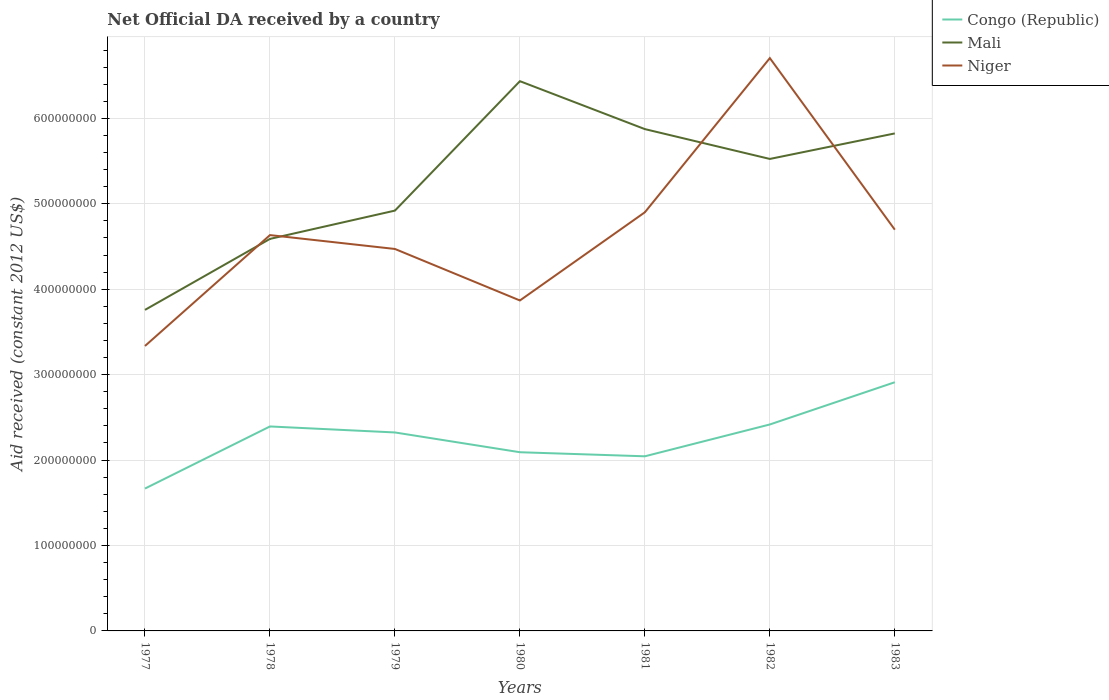Does the line corresponding to Congo (Republic) intersect with the line corresponding to Mali?
Offer a very short reply. No. Across all years, what is the maximum net official development assistance aid received in Congo (Republic)?
Your answer should be compact. 1.67e+08. In which year was the net official development assistance aid received in Congo (Republic) maximum?
Provide a short and direct response. 1977. What is the total net official development assistance aid received in Niger in the graph?
Provide a short and direct response. -1.36e+08. What is the difference between the highest and the second highest net official development assistance aid received in Mali?
Provide a short and direct response. 2.68e+08. How many years are there in the graph?
Provide a short and direct response. 7. Does the graph contain grids?
Keep it short and to the point. Yes. How many legend labels are there?
Your answer should be compact. 3. How are the legend labels stacked?
Keep it short and to the point. Vertical. What is the title of the graph?
Provide a short and direct response. Net Official DA received by a country. Does "European Union" appear as one of the legend labels in the graph?
Keep it short and to the point. No. What is the label or title of the Y-axis?
Your response must be concise. Aid received (constant 2012 US$). What is the Aid received (constant 2012 US$) in Congo (Republic) in 1977?
Offer a very short reply. 1.67e+08. What is the Aid received (constant 2012 US$) in Mali in 1977?
Keep it short and to the point. 3.76e+08. What is the Aid received (constant 2012 US$) of Niger in 1977?
Your answer should be very brief. 3.34e+08. What is the Aid received (constant 2012 US$) in Congo (Republic) in 1978?
Your response must be concise. 2.39e+08. What is the Aid received (constant 2012 US$) of Mali in 1978?
Your answer should be very brief. 4.59e+08. What is the Aid received (constant 2012 US$) in Niger in 1978?
Give a very brief answer. 4.63e+08. What is the Aid received (constant 2012 US$) in Congo (Republic) in 1979?
Offer a very short reply. 2.32e+08. What is the Aid received (constant 2012 US$) in Mali in 1979?
Your answer should be very brief. 4.92e+08. What is the Aid received (constant 2012 US$) of Niger in 1979?
Keep it short and to the point. 4.47e+08. What is the Aid received (constant 2012 US$) in Congo (Republic) in 1980?
Your answer should be very brief. 2.09e+08. What is the Aid received (constant 2012 US$) in Mali in 1980?
Your answer should be very brief. 6.44e+08. What is the Aid received (constant 2012 US$) in Niger in 1980?
Give a very brief answer. 3.87e+08. What is the Aid received (constant 2012 US$) in Congo (Republic) in 1981?
Your answer should be very brief. 2.04e+08. What is the Aid received (constant 2012 US$) of Mali in 1981?
Keep it short and to the point. 5.87e+08. What is the Aid received (constant 2012 US$) of Niger in 1981?
Ensure brevity in your answer.  4.90e+08. What is the Aid received (constant 2012 US$) of Congo (Republic) in 1982?
Ensure brevity in your answer.  2.42e+08. What is the Aid received (constant 2012 US$) of Mali in 1982?
Ensure brevity in your answer.  5.53e+08. What is the Aid received (constant 2012 US$) of Niger in 1982?
Give a very brief answer. 6.71e+08. What is the Aid received (constant 2012 US$) in Congo (Republic) in 1983?
Provide a short and direct response. 2.91e+08. What is the Aid received (constant 2012 US$) of Mali in 1983?
Ensure brevity in your answer.  5.82e+08. What is the Aid received (constant 2012 US$) of Niger in 1983?
Your response must be concise. 4.70e+08. Across all years, what is the maximum Aid received (constant 2012 US$) of Congo (Republic)?
Provide a succinct answer. 2.91e+08. Across all years, what is the maximum Aid received (constant 2012 US$) of Mali?
Your response must be concise. 6.44e+08. Across all years, what is the maximum Aid received (constant 2012 US$) of Niger?
Your answer should be compact. 6.71e+08. Across all years, what is the minimum Aid received (constant 2012 US$) in Congo (Republic)?
Offer a terse response. 1.67e+08. Across all years, what is the minimum Aid received (constant 2012 US$) of Mali?
Your answer should be compact. 3.76e+08. Across all years, what is the minimum Aid received (constant 2012 US$) in Niger?
Provide a succinct answer. 3.34e+08. What is the total Aid received (constant 2012 US$) of Congo (Republic) in the graph?
Offer a terse response. 1.58e+09. What is the total Aid received (constant 2012 US$) of Mali in the graph?
Offer a very short reply. 3.69e+09. What is the total Aid received (constant 2012 US$) of Niger in the graph?
Your response must be concise. 3.26e+09. What is the difference between the Aid received (constant 2012 US$) in Congo (Republic) in 1977 and that in 1978?
Your response must be concise. -7.27e+07. What is the difference between the Aid received (constant 2012 US$) in Mali in 1977 and that in 1978?
Your answer should be compact. -8.31e+07. What is the difference between the Aid received (constant 2012 US$) in Niger in 1977 and that in 1978?
Your answer should be compact. -1.30e+08. What is the difference between the Aid received (constant 2012 US$) of Congo (Republic) in 1977 and that in 1979?
Provide a succinct answer. -6.57e+07. What is the difference between the Aid received (constant 2012 US$) in Mali in 1977 and that in 1979?
Make the answer very short. -1.16e+08. What is the difference between the Aid received (constant 2012 US$) in Niger in 1977 and that in 1979?
Keep it short and to the point. -1.14e+08. What is the difference between the Aid received (constant 2012 US$) of Congo (Republic) in 1977 and that in 1980?
Provide a short and direct response. -4.25e+07. What is the difference between the Aid received (constant 2012 US$) in Mali in 1977 and that in 1980?
Provide a succinct answer. -2.68e+08. What is the difference between the Aid received (constant 2012 US$) in Niger in 1977 and that in 1980?
Give a very brief answer. -5.33e+07. What is the difference between the Aid received (constant 2012 US$) in Congo (Republic) in 1977 and that in 1981?
Your answer should be very brief. -3.78e+07. What is the difference between the Aid received (constant 2012 US$) in Mali in 1977 and that in 1981?
Offer a very short reply. -2.12e+08. What is the difference between the Aid received (constant 2012 US$) in Niger in 1977 and that in 1981?
Your answer should be compact. -1.57e+08. What is the difference between the Aid received (constant 2012 US$) of Congo (Republic) in 1977 and that in 1982?
Give a very brief answer. -7.50e+07. What is the difference between the Aid received (constant 2012 US$) of Mali in 1977 and that in 1982?
Make the answer very short. -1.77e+08. What is the difference between the Aid received (constant 2012 US$) of Niger in 1977 and that in 1982?
Ensure brevity in your answer.  -3.37e+08. What is the difference between the Aid received (constant 2012 US$) in Congo (Republic) in 1977 and that in 1983?
Offer a terse response. -1.24e+08. What is the difference between the Aid received (constant 2012 US$) in Mali in 1977 and that in 1983?
Your answer should be very brief. -2.07e+08. What is the difference between the Aid received (constant 2012 US$) of Niger in 1977 and that in 1983?
Make the answer very short. -1.36e+08. What is the difference between the Aid received (constant 2012 US$) of Congo (Republic) in 1978 and that in 1979?
Give a very brief answer. 7.03e+06. What is the difference between the Aid received (constant 2012 US$) in Mali in 1978 and that in 1979?
Ensure brevity in your answer.  -3.31e+07. What is the difference between the Aid received (constant 2012 US$) of Niger in 1978 and that in 1979?
Keep it short and to the point. 1.62e+07. What is the difference between the Aid received (constant 2012 US$) of Congo (Republic) in 1978 and that in 1980?
Ensure brevity in your answer.  3.02e+07. What is the difference between the Aid received (constant 2012 US$) in Mali in 1978 and that in 1980?
Offer a very short reply. -1.85e+08. What is the difference between the Aid received (constant 2012 US$) in Niger in 1978 and that in 1980?
Offer a very short reply. 7.65e+07. What is the difference between the Aid received (constant 2012 US$) in Congo (Republic) in 1978 and that in 1981?
Make the answer very short. 3.49e+07. What is the difference between the Aid received (constant 2012 US$) in Mali in 1978 and that in 1981?
Offer a very short reply. -1.29e+08. What is the difference between the Aid received (constant 2012 US$) of Niger in 1978 and that in 1981?
Provide a short and direct response. -2.67e+07. What is the difference between the Aid received (constant 2012 US$) of Congo (Republic) in 1978 and that in 1982?
Keep it short and to the point. -2.32e+06. What is the difference between the Aid received (constant 2012 US$) in Mali in 1978 and that in 1982?
Keep it short and to the point. -9.36e+07. What is the difference between the Aid received (constant 2012 US$) in Niger in 1978 and that in 1982?
Offer a very short reply. -2.07e+08. What is the difference between the Aid received (constant 2012 US$) in Congo (Republic) in 1978 and that in 1983?
Your response must be concise. -5.18e+07. What is the difference between the Aid received (constant 2012 US$) of Mali in 1978 and that in 1983?
Your answer should be compact. -1.23e+08. What is the difference between the Aid received (constant 2012 US$) of Niger in 1978 and that in 1983?
Make the answer very short. -6.33e+06. What is the difference between the Aid received (constant 2012 US$) in Congo (Republic) in 1979 and that in 1980?
Your answer should be very brief. 2.32e+07. What is the difference between the Aid received (constant 2012 US$) of Mali in 1979 and that in 1980?
Your answer should be compact. -1.52e+08. What is the difference between the Aid received (constant 2012 US$) in Niger in 1979 and that in 1980?
Offer a terse response. 6.03e+07. What is the difference between the Aid received (constant 2012 US$) in Congo (Republic) in 1979 and that in 1981?
Make the answer very short. 2.79e+07. What is the difference between the Aid received (constant 2012 US$) of Mali in 1979 and that in 1981?
Your answer should be compact. -9.54e+07. What is the difference between the Aid received (constant 2012 US$) of Niger in 1979 and that in 1981?
Make the answer very short. -4.30e+07. What is the difference between the Aid received (constant 2012 US$) of Congo (Republic) in 1979 and that in 1982?
Keep it short and to the point. -9.35e+06. What is the difference between the Aid received (constant 2012 US$) in Mali in 1979 and that in 1982?
Your response must be concise. -6.05e+07. What is the difference between the Aid received (constant 2012 US$) of Niger in 1979 and that in 1982?
Give a very brief answer. -2.23e+08. What is the difference between the Aid received (constant 2012 US$) in Congo (Republic) in 1979 and that in 1983?
Your answer should be compact. -5.88e+07. What is the difference between the Aid received (constant 2012 US$) of Mali in 1979 and that in 1983?
Make the answer very short. -9.04e+07. What is the difference between the Aid received (constant 2012 US$) of Niger in 1979 and that in 1983?
Offer a very short reply. -2.26e+07. What is the difference between the Aid received (constant 2012 US$) in Congo (Republic) in 1980 and that in 1981?
Keep it short and to the point. 4.76e+06. What is the difference between the Aid received (constant 2012 US$) of Mali in 1980 and that in 1981?
Make the answer very short. 5.61e+07. What is the difference between the Aid received (constant 2012 US$) of Niger in 1980 and that in 1981?
Your answer should be very brief. -1.03e+08. What is the difference between the Aid received (constant 2012 US$) of Congo (Republic) in 1980 and that in 1982?
Offer a very short reply. -3.25e+07. What is the difference between the Aid received (constant 2012 US$) of Mali in 1980 and that in 1982?
Keep it short and to the point. 9.10e+07. What is the difference between the Aid received (constant 2012 US$) in Niger in 1980 and that in 1982?
Offer a terse response. -2.84e+08. What is the difference between the Aid received (constant 2012 US$) in Congo (Republic) in 1980 and that in 1983?
Keep it short and to the point. -8.19e+07. What is the difference between the Aid received (constant 2012 US$) of Mali in 1980 and that in 1983?
Offer a very short reply. 6.12e+07. What is the difference between the Aid received (constant 2012 US$) of Niger in 1980 and that in 1983?
Make the answer very short. -8.28e+07. What is the difference between the Aid received (constant 2012 US$) in Congo (Republic) in 1981 and that in 1982?
Your answer should be very brief. -3.73e+07. What is the difference between the Aid received (constant 2012 US$) in Mali in 1981 and that in 1982?
Ensure brevity in your answer.  3.49e+07. What is the difference between the Aid received (constant 2012 US$) in Niger in 1981 and that in 1982?
Make the answer very short. -1.80e+08. What is the difference between the Aid received (constant 2012 US$) of Congo (Republic) in 1981 and that in 1983?
Give a very brief answer. -8.67e+07. What is the difference between the Aid received (constant 2012 US$) in Mali in 1981 and that in 1983?
Your answer should be compact. 5.04e+06. What is the difference between the Aid received (constant 2012 US$) of Niger in 1981 and that in 1983?
Your answer should be compact. 2.04e+07. What is the difference between the Aid received (constant 2012 US$) in Congo (Republic) in 1982 and that in 1983?
Ensure brevity in your answer.  -4.94e+07. What is the difference between the Aid received (constant 2012 US$) of Mali in 1982 and that in 1983?
Provide a short and direct response. -2.99e+07. What is the difference between the Aid received (constant 2012 US$) in Niger in 1982 and that in 1983?
Your answer should be compact. 2.01e+08. What is the difference between the Aid received (constant 2012 US$) in Congo (Republic) in 1977 and the Aid received (constant 2012 US$) in Mali in 1978?
Your response must be concise. -2.92e+08. What is the difference between the Aid received (constant 2012 US$) of Congo (Republic) in 1977 and the Aid received (constant 2012 US$) of Niger in 1978?
Your response must be concise. -2.97e+08. What is the difference between the Aid received (constant 2012 US$) of Mali in 1977 and the Aid received (constant 2012 US$) of Niger in 1978?
Give a very brief answer. -8.76e+07. What is the difference between the Aid received (constant 2012 US$) of Congo (Republic) in 1977 and the Aid received (constant 2012 US$) of Mali in 1979?
Ensure brevity in your answer.  -3.25e+08. What is the difference between the Aid received (constant 2012 US$) in Congo (Republic) in 1977 and the Aid received (constant 2012 US$) in Niger in 1979?
Your response must be concise. -2.80e+08. What is the difference between the Aid received (constant 2012 US$) in Mali in 1977 and the Aid received (constant 2012 US$) in Niger in 1979?
Give a very brief answer. -7.13e+07. What is the difference between the Aid received (constant 2012 US$) of Congo (Republic) in 1977 and the Aid received (constant 2012 US$) of Mali in 1980?
Ensure brevity in your answer.  -4.77e+08. What is the difference between the Aid received (constant 2012 US$) of Congo (Republic) in 1977 and the Aid received (constant 2012 US$) of Niger in 1980?
Make the answer very short. -2.20e+08. What is the difference between the Aid received (constant 2012 US$) in Mali in 1977 and the Aid received (constant 2012 US$) in Niger in 1980?
Keep it short and to the point. -1.10e+07. What is the difference between the Aid received (constant 2012 US$) in Congo (Republic) in 1977 and the Aid received (constant 2012 US$) in Mali in 1981?
Keep it short and to the point. -4.21e+08. What is the difference between the Aid received (constant 2012 US$) of Congo (Republic) in 1977 and the Aid received (constant 2012 US$) of Niger in 1981?
Make the answer very short. -3.23e+08. What is the difference between the Aid received (constant 2012 US$) of Mali in 1977 and the Aid received (constant 2012 US$) of Niger in 1981?
Offer a very short reply. -1.14e+08. What is the difference between the Aid received (constant 2012 US$) of Congo (Republic) in 1977 and the Aid received (constant 2012 US$) of Mali in 1982?
Your answer should be very brief. -3.86e+08. What is the difference between the Aid received (constant 2012 US$) of Congo (Republic) in 1977 and the Aid received (constant 2012 US$) of Niger in 1982?
Provide a succinct answer. -5.04e+08. What is the difference between the Aid received (constant 2012 US$) of Mali in 1977 and the Aid received (constant 2012 US$) of Niger in 1982?
Your response must be concise. -2.95e+08. What is the difference between the Aid received (constant 2012 US$) of Congo (Republic) in 1977 and the Aid received (constant 2012 US$) of Mali in 1983?
Offer a terse response. -4.16e+08. What is the difference between the Aid received (constant 2012 US$) of Congo (Republic) in 1977 and the Aid received (constant 2012 US$) of Niger in 1983?
Offer a very short reply. -3.03e+08. What is the difference between the Aid received (constant 2012 US$) in Mali in 1977 and the Aid received (constant 2012 US$) in Niger in 1983?
Make the answer very short. -9.39e+07. What is the difference between the Aid received (constant 2012 US$) in Congo (Republic) in 1978 and the Aid received (constant 2012 US$) in Mali in 1979?
Provide a succinct answer. -2.53e+08. What is the difference between the Aid received (constant 2012 US$) of Congo (Republic) in 1978 and the Aid received (constant 2012 US$) of Niger in 1979?
Your answer should be very brief. -2.08e+08. What is the difference between the Aid received (constant 2012 US$) in Mali in 1978 and the Aid received (constant 2012 US$) in Niger in 1979?
Keep it short and to the point. 1.18e+07. What is the difference between the Aid received (constant 2012 US$) in Congo (Republic) in 1978 and the Aid received (constant 2012 US$) in Mali in 1980?
Provide a succinct answer. -4.04e+08. What is the difference between the Aid received (constant 2012 US$) of Congo (Republic) in 1978 and the Aid received (constant 2012 US$) of Niger in 1980?
Your answer should be very brief. -1.47e+08. What is the difference between the Aid received (constant 2012 US$) of Mali in 1978 and the Aid received (constant 2012 US$) of Niger in 1980?
Your answer should be very brief. 7.21e+07. What is the difference between the Aid received (constant 2012 US$) in Congo (Republic) in 1978 and the Aid received (constant 2012 US$) in Mali in 1981?
Ensure brevity in your answer.  -3.48e+08. What is the difference between the Aid received (constant 2012 US$) in Congo (Republic) in 1978 and the Aid received (constant 2012 US$) in Niger in 1981?
Offer a very short reply. -2.51e+08. What is the difference between the Aid received (constant 2012 US$) of Mali in 1978 and the Aid received (constant 2012 US$) of Niger in 1981?
Ensure brevity in your answer.  -3.12e+07. What is the difference between the Aid received (constant 2012 US$) in Congo (Republic) in 1978 and the Aid received (constant 2012 US$) in Mali in 1982?
Your answer should be very brief. -3.13e+08. What is the difference between the Aid received (constant 2012 US$) in Congo (Republic) in 1978 and the Aid received (constant 2012 US$) in Niger in 1982?
Your answer should be compact. -4.31e+08. What is the difference between the Aid received (constant 2012 US$) in Mali in 1978 and the Aid received (constant 2012 US$) in Niger in 1982?
Provide a succinct answer. -2.12e+08. What is the difference between the Aid received (constant 2012 US$) of Congo (Republic) in 1978 and the Aid received (constant 2012 US$) of Mali in 1983?
Offer a very short reply. -3.43e+08. What is the difference between the Aid received (constant 2012 US$) of Congo (Republic) in 1978 and the Aid received (constant 2012 US$) of Niger in 1983?
Your answer should be very brief. -2.30e+08. What is the difference between the Aid received (constant 2012 US$) in Mali in 1978 and the Aid received (constant 2012 US$) in Niger in 1983?
Ensure brevity in your answer.  -1.08e+07. What is the difference between the Aid received (constant 2012 US$) of Congo (Republic) in 1979 and the Aid received (constant 2012 US$) of Mali in 1980?
Offer a very short reply. -4.11e+08. What is the difference between the Aid received (constant 2012 US$) of Congo (Republic) in 1979 and the Aid received (constant 2012 US$) of Niger in 1980?
Offer a very short reply. -1.55e+08. What is the difference between the Aid received (constant 2012 US$) in Mali in 1979 and the Aid received (constant 2012 US$) in Niger in 1980?
Provide a succinct answer. 1.05e+08. What is the difference between the Aid received (constant 2012 US$) of Congo (Republic) in 1979 and the Aid received (constant 2012 US$) of Mali in 1981?
Provide a short and direct response. -3.55e+08. What is the difference between the Aid received (constant 2012 US$) of Congo (Republic) in 1979 and the Aid received (constant 2012 US$) of Niger in 1981?
Make the answer very short. -2.58e+08. What is the difference between the Aid received (constant 2012 US$) of Mali in 1979 and the Aid received (constant 2012 US$) of Niger in 1981?
Make the answer very short. 1.96e+06. What is the difference between the Aid received (constant 2012 US$) of Congo (Republic) in 1979 and the Aid received (constant 2012 US$) of Mali in 1982?
Keep it short and to the point. -3.20e+08. What is the difference between the Aid received (constant 2012 US$) of Congo (Republic) in 1979 and the Aid received (constant 2012 US$) of Niger in 1982?
Keep it short and to the point. -4.38e+08. What is the difference between the Aid received (constant 2012 US$) in Mali in 1979 and the Aid received (constant 2012 US$) in Niger in 1982?
Your answer should be very brief. -1.79e+08. What is the difference between the Aid received (constant 2012 US$) of Congo (Republic) in 1979 and the Aid received (constant 2012 US$) of Mali in 1983?
Ensure brevity in your answer.  -3.50e+08. What is the difference between the Aid received (constant 2012 US$) of Congo (Republic) in 1979 and the Aid received (constant 2012 US$) of Niger in 1983?
Offer a very short reply. -2.37e+08. What is the difference between the Aid received (constant 2012 US$) in Mali in 1979 and the Aid received (constant 2012 US$) in Niger in 1983?
Give a very brief answer. 2.24e+07. What is the difference between the Aid received (constant 2012 US$) of Congo (Republic) in 1980 and the Aid received (constant 2012 US$) of Mali in 1981?
Offer a very short reply. -3.78e+08. What is the difference between the Aid received (constant 2012 US$) in Congo (Republic) in 1980 and the Aid received (constant 2012 US$) in Niger in 1981?
Give a very brief answer. -2.81e+08. What is the difference between the Aid received (constant 2012 US$) in Mali in 1980 and the Aid received (constant 2012 US$) in Niger in 1981?
Give a very brief answer. 1.53e+08. What is the difference between the Aid received (constant 2012 US$) of Congo (Republic) in 1980 and the Aid received (constant 2012 US$) of Mali in 1982?
Give a very brief answer. -3.43e+08. What is the difference between the Aid received (constant 2012 US$) of Congo (Republic) in 1980 and the Aid received (constant 2012 US$) of Niger in 1982?
Your answer should be compact. -4.61e+08. What is the difference between the Aid received (constant 2012 US$) of Mali in 1980 and the Aid received (constant 2012 US$) of Niger in 1982?
Make the answer very short. -2.70e+07. What is the difference between the Aid received (constant 2012 US$) in Congo (Republic) in 1980 and the Aid received (constant 2012 US$) in Mali in 1983?
Your response must be concise. -3.73e+08. What is the difference between the Aid received (constant 2012 US$) in Congo (Republic) in 1980 and the Aid received (constant 2012 US$) in Niger in 1983?
Your response must be concise. -2.61e+08. What is the difference between the Aid received (constant 2012 US$) in Mali in 1980 and the Aid received (constant 2012 US$) in Niger in 1983?
Your answer should be very brief. 1.74e+08. What is the difference between the Aid received (constant 2012 US$) in Congo (Republic) in 1981 and the Aid received (constant 2012 US$) in Mali in 1982?
Keep it short and to the point. -3.48e+08. What is the difference between the Aid received (constant 2012 US$) of Congo (Republic) in 1981 and the Aid received (constant 2012 US$) of Niger in 1982?
Make the answer very short. -4.66e+08. What is the difference between the Aid received (constant 2012 US$) of Mali in 1981 and the Aid received (constant 2012 US$) of Niger in 1982?
Offer a terse response. -8.31e+07. What is the difference between the Aid received (constant 2012 US$) of Congo (Republic) in 1981 and the Aid received (constant 2012 US$) of Mali in 1983?
Your response must be concise. -3.78e+08. What is the difference between the Aid received (constant 2012 US$) in Congo (Republic) in 1981 and the Aid received (constant 2012 US$) in Niger in 1983?
Provide a succinct answer. -2.65e+08. What is the difference between the Aid received (constant 2012 US$) in Mali in 1981 and the Aid received (constant 2012 US$) in Niger in 1983?
Provide a short and direct response. 1.18e+08. What is the difference between the Aid received (constant 2012 US$) of Congo (Republic) in 1982 and the Aid received (constant 2012 US$) of Mali in 1983?
Offer a terse response. -3.41e+08. What is the difference between the Aid received (constant 2012 US$) of Congo (Republic) in 1982 and the Aid received (constant 2012 US$) of Niger in 1983?
Provide a short and direct response. -2.28e+08. What is the difference between the Aid received (constant 2012 US$) in Mali in 1982 and the Aid received (constant 2012 US$) in Niger in 1983?
Offer a very short reply. 8.28e+07. What is the average Aid received (constant 2012 US$) of Congo (Republic) per year?
Give a very brief answer. 2.26e+08. What is the average Aid received (constant 2012 US$) in Mali per year?
Give a very brief answer. 5.28e+08. What is the average Aid received (constant 2012 US$) in Niger per year?
Your answer should be compact. 4.66e+08. In the year 1977, what is the difference between the Aid received (constant 2012 US$) in Congo (Republic) and Aid received (constant 2012 US$) in Mali?
Ensure brevity in your answer.  -2.09e+08. In the year 1977, what is the difference between the Aid received (constant 2012 US$) of Congo (Republic) and Aid received (constant 2012 US$) of Niger?
Ensure brevity in your answer.  -1.67e+08. In the year 1977, what is the difference between the Aid received (constant 2012 US$) of Mali and Aid received (constant 2012 US$) of Niger?
Your response must be concise. 4.22e+07. In the year 1978, what is the difference between the Aid received (constant 2012 US$) of Congo (Republic) and Aid received (constant 2012 US$) of Mali?
Give a very brief answer. -2.20e+08. In the year 1978, what is the difference between the Aid received (constant 2012 US$) of Congo (Republic) and Aid received (constant 2012 US$) of Niger?
Make the answer very short. -2.24e+08. In the year 1978, what is the difference between the Aid received (constant 2012 US$) of Mali and Aid received (constant 2012 US$) of Niger?
Your response must be concise. -4.44e+06. In the year 1979, what is the difference between the Aid received (constant 2012 US$) of Congo (Republic) and Aid received (constant 2012 US$) of Mali?
Ensure brevity in your answer.  -2.60e+08. In the year 1979, what is the difference between the Aid received (constant 2012 US$) of Congo (Republic) and Aid received (constant 2012 US$) of Niger?
Your response must be concise. -2.15e+08. In the year 1979, what is the difference between the Aid received (constant 2012 US$) in Mali and Aid received (constant 2012 US$) in Niger?
Ensure brevity in your answer.  4.49e+07. In the year 1980, what is the difference between the Aid received (constant 2012 US$) of Congo (Republic) and Aid received (constant 2012 US$) of Mali?
Ensure brevity in your answer.  -4.34e+08. In the year 1980, what is the difference between the Aid received (constant 2012 US$) of Congo (Republic) and Aid received (constant 2012 US$) of Niger?
Provide a short and direct response. -1.78e+08. In the year 1980, what is the difference between the Aid received (constant 2012 US$) in Mali and Aid received (constant 2012 US$) in Niger?
Your response must be concise. 2.57e+08. In the year 1981, what is the difference between the Aid received (constant 2012 US$) in Congo (Republic) and Aid received (constant 2012 US$) in Mali?
Make the answer very short. -3.83e+08. In the year 1981, what is the difference between the Aid received (constant 2012 US$) of Congo (Republic) and Aid received (constant 2012 US$) of Niger?
Offer a very short reply. -2.86e+08. In the year 1981, what is the difference between the Aid received (constant 2012 US$) in Mali and Aid received (constant 2012 US$) in Niger?
Make the answer very short. 9.74e+07. In the year 1982, what is the difference between the Aid received (constant 2012 US$) of Congo (Republic) and Aid received (constant 2012 US$) of Mali?
Offer a very short reply. -3.11e+08. In the year 1982, what is the difference between the Aid received (constant 2012 US$) in Congo (Republic) and Aid received (constant 2012 US$) in Niger?
Keep it short and to the point. -4.29e+08. In the year 1982, what is the difference between the Aid received (constant 2012 US$) in Mali and Aid received (constant 2012 US$) in Niger?
Give a very brief answer. -1.18e+08. In the year 1983, what is the difference between the Aid received (constant 2012 US$) in Congo (Republic) and Aid received (constant 2012 US$) in Mali?
Ensure brevity in your answer.  -2.91e+08. In the year 1983, what is the difference between the Aid received (constant 2012 US$) in Congo (Republic) and Aid received (constant 2012 US$) in Niger?
Make the answer very short. -1.79e+08. In the year 1983, what is the difference between the Aid received (constant 2012 US$) of Mali and Aid received (constant 2012 US$) of Niger?
Your answer should be very brief. 1.13e+08. What is the ratio of the Aid received (constant 2012 US$) of Congo (Republic) in 1977 to that in 1978?
Keep it short and to the point. 0.7. What is the ratio of the Aid received (constant 2012 US$) of Mali in 1977 to that in 1978?
Your answer should be very brief. 0.82. What is the ratio of the Aid received (constant 2012 US$) of Niger in 1977 to that in 1978?
Provide a short and direct response. 0.72. What is the ratio of the Aid received (constant 2012 US$) of Congo (Republic) in 1977 to that in 1979?
Your answer should be very brief. 0.72. What is the ratio of the Aid received (constant 2012 US$) in Mali in 1977 to that in 1979?
Your answer should be compact. 0.76. What is the ratio of the Aid received (constant 2012 US$) of Niger in 1977 to that in 1979?
Your response must be concise. 0.75. What is the ratio of the Aid received (constant 2012 US$) of Congo (Republic) in 1977 to that in 1980?
Provide a succinct answer. 0.8. What is the ratio of the Aid received (constant 2012 US$) of Mali in 1977 to that in 1980?
Make the answer very short. 0.58. What is the ratio of the Aid received (constant 2012 US$) in Niger in 1977 to that in 1980?
Provide a succinct answer. 0.86. What is the ratio of the Aid received (constant 2012 US$) in Congo (Republic) in 1977 to that in 1981?
Provide a short and direct response. 0.82. What is the ratio of the Aid received (constant 2012 US$) in Mali in 1977 to that in 1981?
Offer a terse response. 0.64. What is the ratio of the Aid received (constant 2012 US$) of Niger in 1977 to that in 1981?
Ensure brevity in your answer.  0.68. What is the ratio of the Aid received (constant 2012 US$) of Congo (Republic) in 1977 to that in 1982?
Your response must be concise. 0.69. What is the ratio of the Aid received (constant 2012 US$) in Mali in 1977 to that in 1982?
Make the answer very short. 0.68. What is the ratio of the Aid received (constant 2012 US$) in Niger in 1977 to that in 1982?
Make the answer very short. 0.5. What is the ratio of the Aid received (constant 2012 US$) in Congo (Republic) in 1977 to that in 1983?
Provide a short and direct response. 0.57. What is the ratio of the Aid received (constant 2012 US$) in Mali in 1977 to that in 1983?
Your response must be concise. 0.65. What is the ratio of the Aid received (constant 2012 US$) in Niger in 1977 to that in 1983?
Keep it short and to the point. 0.71. What is the ratio of the Aid received (constant 2012 US$) in Congo (Republic) in 1978 to that in 1979?
Provide a short and direct response. 1.03. What is the ratio of the Aid received (constant 2012 US$) of Mali in 1978 to that in 1979?
Ensure brevity in your answer.  0.93. What is the ratio of the Aid received (constant 2012 US$) in Niger in 1978 to that in 1979?
Give a very brief answer. 1.04. What is the ratio of the Aid received (constant 2012 US$) in Congo (Republic) in 1978 to that in 1980?
Keep it short and to the point. 1.14. What is the ratio of the Aid received (constant 2012 US$) of Mali in 1978 to that in 1980?
Offer a very short reply. 0.71. What is the ratio of the Aid received (constant 2012 US$) in Niger in 1978 to that in 1980?
Make the answer very short. 1.2. What is the ratio of the Aid received (constant 2012 US$) in Congo (Republic) in 1978 to that in 1981?
Keep it short and to the point. 1.17. What is the ratio of the Aid received (constant 2012 US$) of Mali in 1978 to that in 1981?
Give a very brief answer. 0.78. What is the ratio of the Aid received (constant 2012 US$) of Niger in 1978 to that in 1981?
Provide a succinct answer. 0.95. What is the ratio of the Aid received (constant 2012 US$) in Mali in 1978 to that in 1982?
Ensure brevity in your answer.  0.83. What is the ratio of the Aid received (constant 2012 US$) in Niger in 1978 to that in 1982?
Provide a succinct answer. 0.69. What is the ratio of the Aid received (constant 2012 US$) in Congo (Republic) in 1978 to that in 1983?
Ensure brevity in your answer.  0.82. What is the ratio of the Aid received (constant 2012 US$) in Mali in 1978 to that in 1983?
Give a very brief answer. 0.79. What is the ratio of the Aid received (constant 2012 US$) of Niger in 1978 to that in 1983?
Offer a very short reply. 0.99. What is the ratio of the Aid received (constant 2012 US$) of Congo (Republic) in 1979 to that in 1980?
Provide a short and direct response. 1.11. What is the ratio of the Aid received (constant 2012 US$) of Mali in 1979 to that in 1980?
Make the answer very short. 0.76. What is the ratio of the Aid received (constant 2012 US$) of Niger in 1979 to that in 1980?
Keep it short and to the point. 1.16. What is the ratio of the Aid received (constant 2012 US$) in Congo (Republic) in 1979 to that in 1981?
Offer a terse response. 1.14. What is the ratio of the Aid received (constant 2012 US$) of Mali in 1979 to that in 1981?
Provide a short and direct response. 0.84. What is the ratio of the Aid received (constant 2012 US$) in Niger in 1979 to that in 1981?
Your answer should be compact. 0.91. What is the ratio of the Aid received (constant 2012 US$) in Congo (Republic) in 1979 to that in 1982?
Give a very brief answer. 0.96. What is the ratio of the Aid received (constant 2012 US$) in Mali in 1979 to that in 1982?
Keep it short and to the point. 0.89. What is the ratio of the Aid received (constant 2012 US$) in Niger in 1979 to that in 1982?
Your answer should be compact. 0.67. What is the ratio of the Aid received (constant 2012 US$) in Congo (Republic) in 1979 to that in 1983?
Your answer should be compact. 0.8. What is the ratio of the Aid received (constant 2012 US$) in Mali in 1979 to that in 1983?
Provide a succinct answer. 0.84. What is the ratio of the Aid received (constant 2012 US$) of Niger in 1979 to that in 1983?
Provide a short and direct response. 0.95. What is the ratio of the Aid received (constant 2012 US$) in Congo (Republic) in 1980 to that in 1981?
Give a very brief answer. 1.02. What is the ratio of the Aid received (constant 2012 US$) in Mali in 1980 to that in 1981?
Offer a very short reply. 1.1. What is the ratio of the Aid received (constant 2012 US$) in Niger in 1980 to that in 1981?
Provide a succinct answer. 0.79. What is the ratio of the Aid received (constant 2012 US$) of Congo (Republic) in 1980 to that in 1982?
Ensure brevity in your answer.  0.87. What is the ratio of the Aid received (constant 2012 US$) in Mali in 1980 to that in 1982?
Give a very brief answer. 1.16. What is the ratio of the Aid received (constant 2012 US$) in Niger in 1980 to that in 1982?
Provide a succinct answer. 0.58. What is the ratio of the Aid received (constant 2012 US$) in Congo (Republic) in 1980 to that in 1983?
Your answer should be compact. 0.72. What is the ratio of the Aid received (constant 2012 US$) in Mali in 1980 to that in 1983?
Make the answer very short. 1.1. What is the ratio of the Aid received (constant 2012 US$) of Niger in 1980 to that in 1983?
Provide a short and direct response. 0.82. What is the ratio of the Aid received (constant 2012 US$) in Congo (Republic) in 1981 to that in 1982?
Your response must be concise. 0.85. What is the ratio of the Aid received (constant 2012 US$) in Mali in 1981 to that in 1982?
Give a very brief answer. 1.06. What is the ratio of the Aid received (constant 2012 US$) of Niger in 1981 to that in 1982?
Make the answer very short. 0.73. What is the ratio of the Aid received (constant 2012 US$) in Congo (Republic) in 1981 to that in 1983?
Make the answer very short. 0.7. What is the ratio of the Aid received (constant 2012 US$) in Mali in 1981 to that in 1983?
Your answer should be compact. 1.01. What is the ratio of the Aid received (constant 2012 US$) in Niger in 1981 to that in 1983?
Provide a succinct answer. 1.04. What is the ratio of the Aid received (constant 2012 US$) of Congo (Republic) in 1982 to that in 1983?
Provide a succinct answer. 0.83. What is the ratio of the Aid received (constant 2012 US$) in Mali in 1982 to that in 1983?
Make the answer very short. 0.95. What is the ratio of the Aid received (constant 2012 US$) in Niger in 1982 to that in 1983?
Offer a very short reply. 1.43. What is the difference between the highest and the second highest Aid received (constant 2012 US$) in Congo (Republic)?
Ensure brevity in your answer.  4.94e+07. What is the difference between the highest and the second highest Aid received (constant 2012 US$) in Mali?
Offer a very short reply. 5.61e+07. What is the difference between the highest and the second highest Aid received (constant 2012 US$) of Niger?
Your response must be concise. 1.80e+08. What is the difference between the highest and the lowest Aid received (constant 2012 US$) of Congo (Republic)?
Ensure brevity in your answer.  1.24e+08. What is the difference between the highest and the lowest Aid received (constant 2012 US$) in Mali?
Your answer should be very brief. 2.68e+08. What is the difference between the highest and the lowest Aid received (constant 2012 US$) in Niger?
Your answer should be very brief. 3.37e+08. 